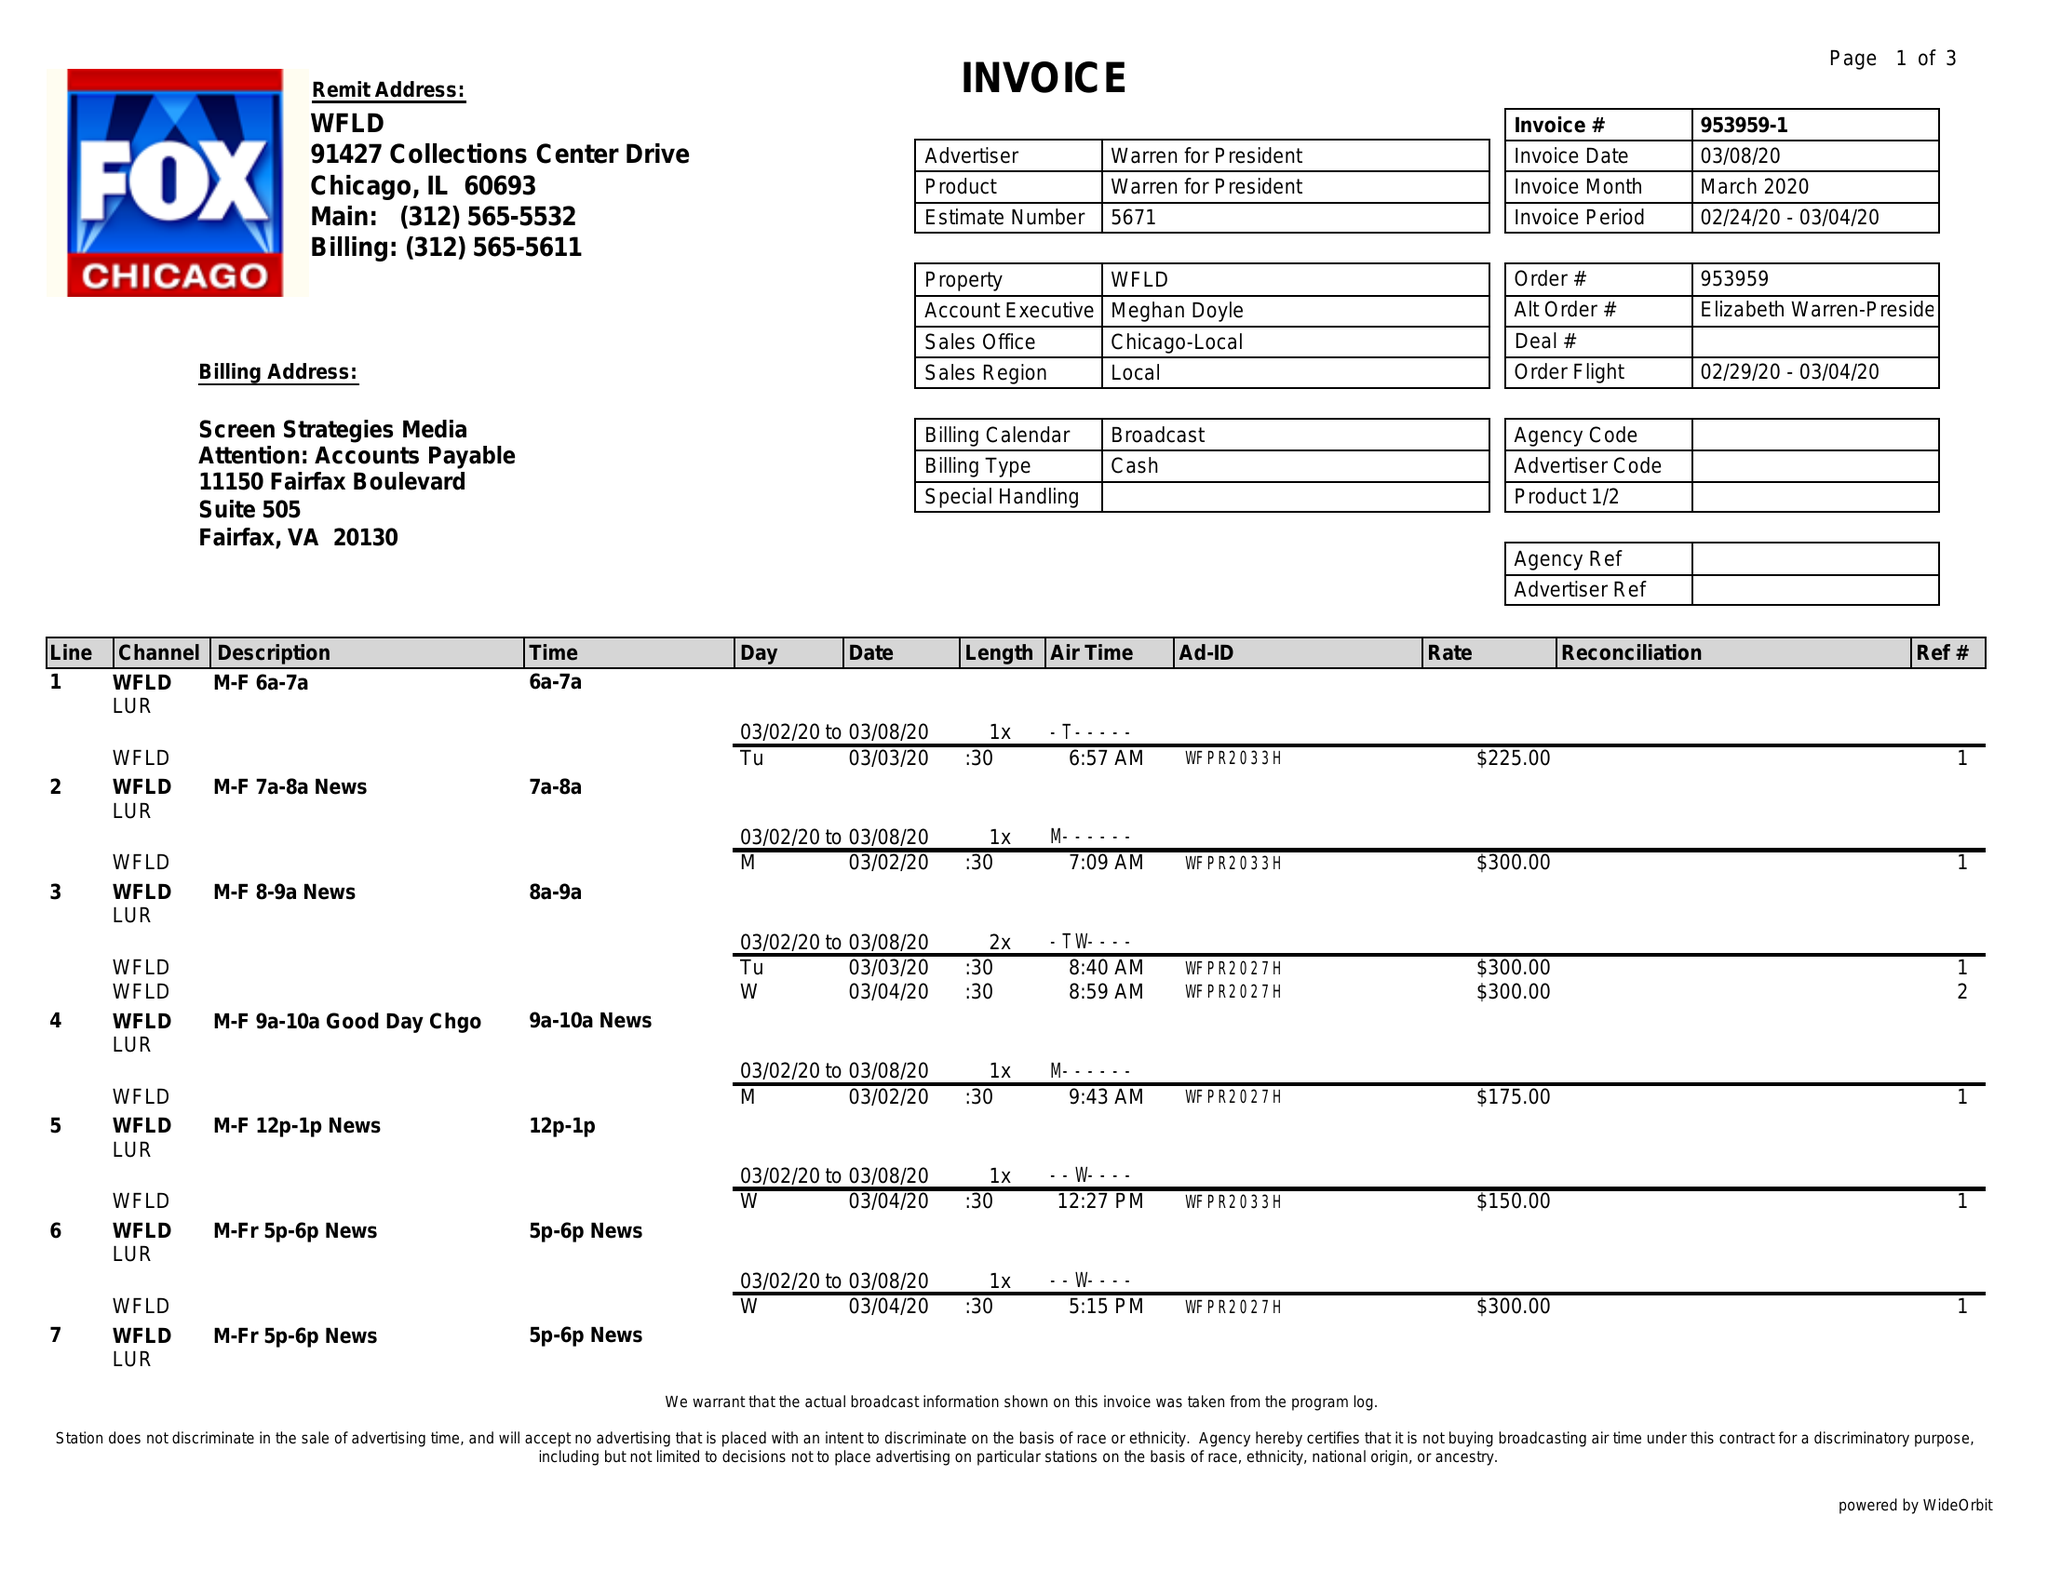What is the value for the gross_amount?
Answer the question using a single word or phrase. 8850.00 